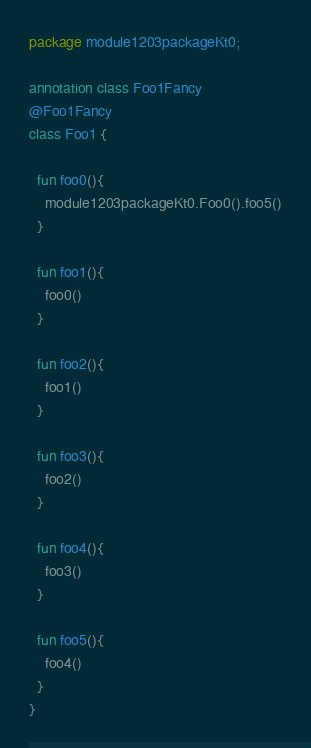Convert code to text. <code><loc_0><loc_0><loc_500><loc_500><_Kotlin_>package module1203packageKt0;

annotation class Foo1Fancy
@Foo1Fancy
class Foo1 {

  fun foo0(){
    module1203packageKt0.Foo0().foo5()
  }

  fun foo1(){
    foo0()
  }

  fun foo2(){
    foo1()
  }

  fun foo3(){
    foo2()
  }

  fun foo4(){
    foo3()
  }

  fun foo5(){
    foo4()
  }
}</code> 